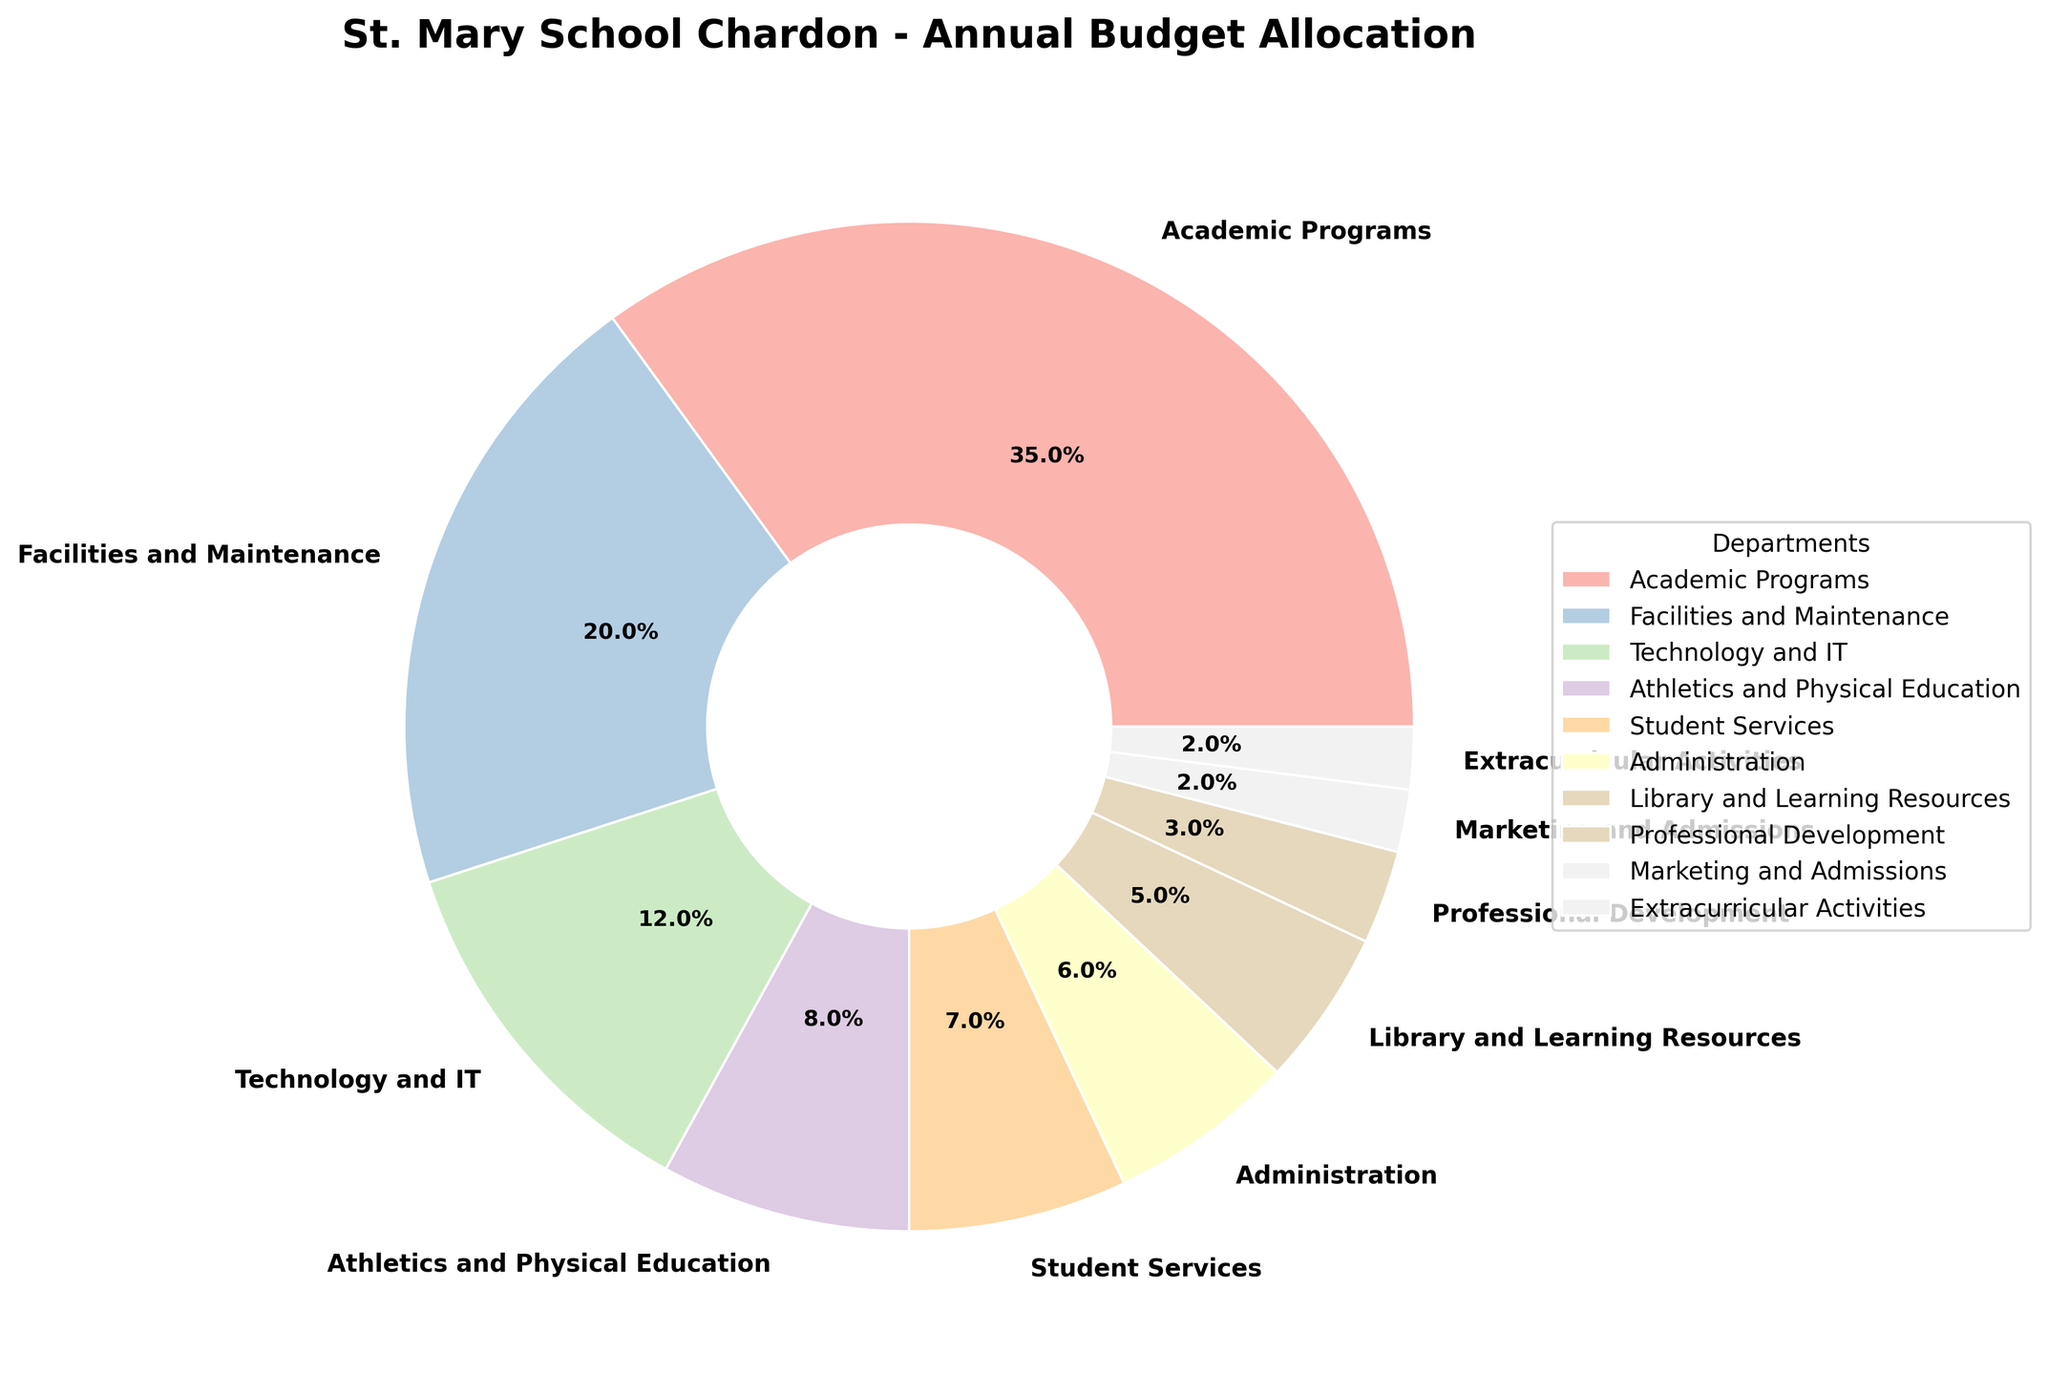What's the largest budget allocation? The largest budget allocation is visually the largest slice in the pie chart, represented by the label with the highest percentage. The "Academic Programs" slice is the largest with 35%.
Answer: 35% Which department has the smallest budget allocation? The smallest budget allocation is represented by the smallest slice in the pie chart, labeled "Marketing and Admissions" and "Extracurricular Activities", each with 2%.
Answer: Marketing and Admissions, Extracurricular Activities How much more is allocated to Academic Programs compared to Athletics and Physical Education? The allocation for Academic Programs is 35%, and for Athletics and Physical Education, it is 8%. The difference is 35% - 8% = 27%.
Answer: 27% Which departments together make up exactly half of the budget allocation? The departments "Academic Programs" (35%) and "Facilities and Maintenance" (20%) together allocate 35% + 20% = 55%, while "Academic Programs" (35%) and "Technology and IT" (12%) together allocate 35% + 12% = 47%. Hence, "Academic Programs" and "Facilities and Maintenance" combined exceed half. To precisely reach half, combining "Academic Programs" (35%) with other smaller departments such as "Technology and IT" (12%), "Athletics and Physical Education" (8%) and "Student Services" (7%) helps fine-tune to exact matches, i.e., Academic Programs (35%) + Technology and IT (12%) = 47% + Student Services (7%) approximately make it.
Answer: Academic Programs and other suitable smaller departments If you combine the budget allocations for Facilities and Maintenance, Technology and IT, and Administration, is it more than the allocation for Academic Programs? First, sum the budget allocations for Facilities and Maintenance (20%), Technology and IT (12%), and Administration (6%): 20% + 12% + 6% = 38%. Since 38% is more than the 35% allocated for Academic Programs, the combined allocation is indeed more.
Answer: Yes Is the allocation for Professional Development lower than the combined allocation for Extracurricular Activities and Marketing and Admissions? The allocation for Professional Development is 3%, while the combined allocation for Extracurricular Activities (2%) and Marketing and Admissions (2%) is 2% + 2% = 4%. Since 3% is less than 4%, the allocation for Professional Development is lower.
Answer: Yes Visually, which color represents the Technology and IT department? The color representing Technology and IT can be identified by looking at the legend that matches the pie chart slice labeled "Technology and IT" with its corresponding color.
Answer: Pastel color (color as per the figure) How much of the budget is allocated to both the Library and Learning Resources and Student Services combined? Add the budget allocations for Library and Learning Resources (5%) and Student Services (7%): 5% + 7% = 12%.
Answer: 12% Which departments have allocations equal to or greater than 20%? The departments with allocations equal to or greater than 20% are identified from the pie chart as "Academic Programs" (35%) and "Facilities and Maintenance" (20%).
Answer: Academic Programs, Facilities and Maintenance 